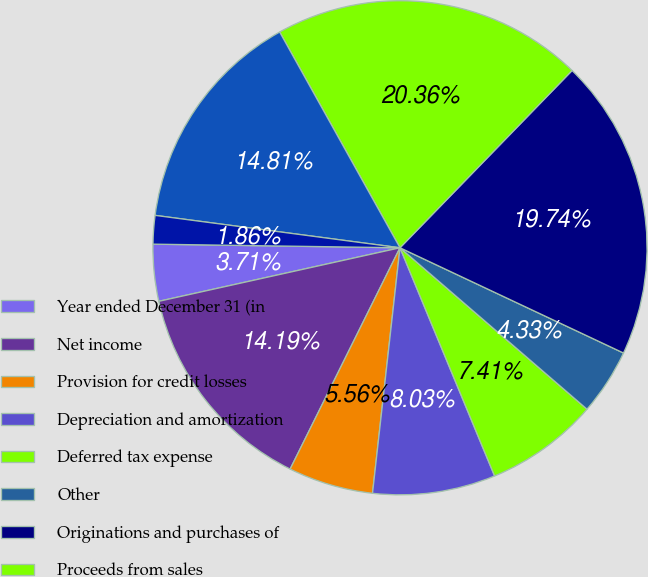Convert chart. <chart><loc_0><loc_0><loc_500><loc_500><pie_chart><fcel>Year ended December 31 (in<fcel>Net income<fcel>Provision for credit losses<fcel>Depreciation and amortization<fcel>Deferred tax expense<fcel>Other<fcel>Originations and purchases of<fcel>Proceeds from sales<fcel>Trading assets<fcel>Securities borrowed<nl><fcel>3.71%<fcel>14.19%<fcel>5.56%<fcel>8.03%<fcel>7.41%<fcel>4.33%<fcel>19.74%<fcel>20.36%<fcel>14.81%<fcel>1.86%<nl></chart> 